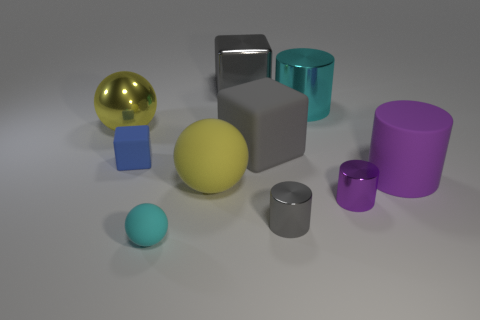Is the size of the yellow thing that is behind the small blue rubber cube the same as the cube behind the yellow metal ball?
Provide a short and direct response. Yes. The blue object that is to the left of the big matte object to the right of the large metal cylinder is what shape?
Provide a short and direct response. Cube. Are there the same number of small rubber cubes to the left of the large metallic ball and large cylinders?
Make the answer very short. No. What is the big sphere behind the tiny object that is on the left side of the tiny matte object that is in front of the blue rubber thing made of?
Provide a succinct answer. Metal. Are there any gray rubber cubes that have the same size as the cyan rubber sphere?
Your answer should be very brief. No. There is a blue rubber thing; what shape is it?
Your answer should be very brief. Cube. What number of cylinders are either small blue rubber objects or small matte objects?
Your answer should be very brief. 0. Are there an equal number of tiny spheres that are left of the blue rubber thing and tiny cylinders that are behind the large yellow shiny ball?
Your answer should be very brief. Yes. How many purple objects are in front of the gray object that is in front of the big gray object in front of the gray shiny block?
Offer a very short reply. 0. The large thing that is the same color as the tiny matte sphere is what shape?
Provide a short and direct response. Cylinder. 